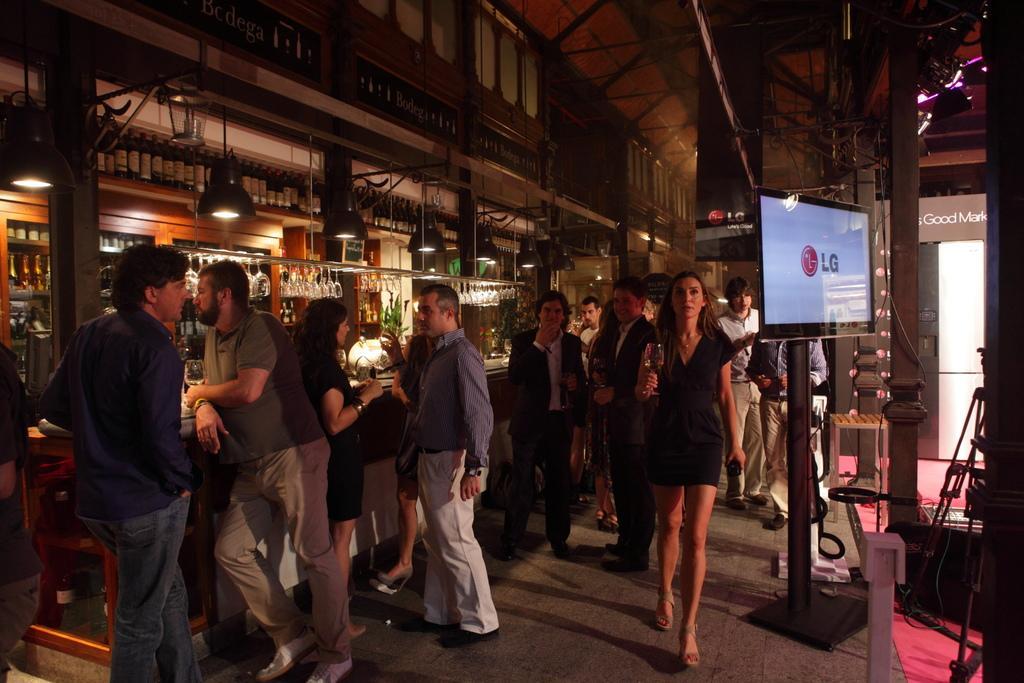Describe this image in one or two sentences. On the right side a beautiful woman is walking, she wore a dress. Beside her there is a television, on the left side it looks like a bar, few people are standing near this. 